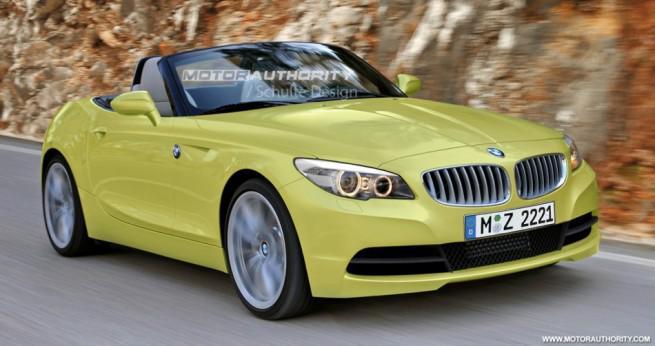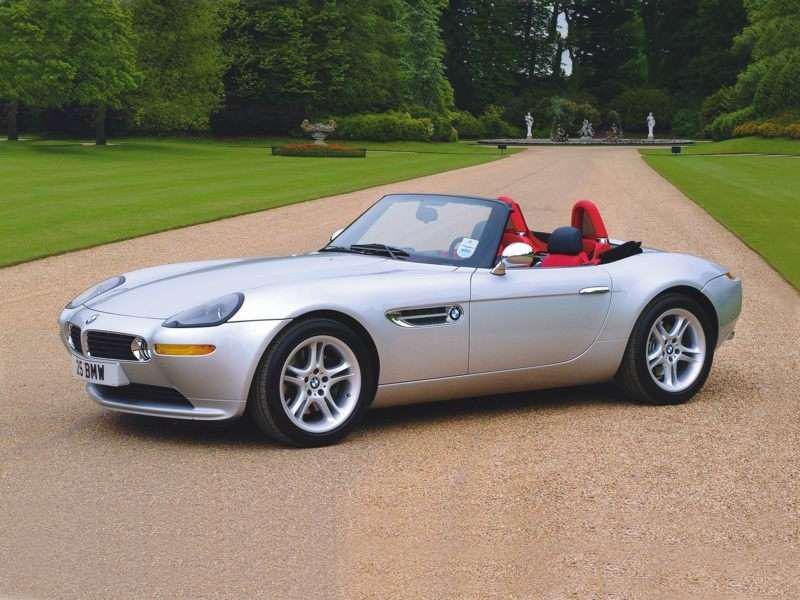The first image is the image on the left, the second image is the image on the right. Evaluate the accuracy of this statement regarding the images: "One of the cars is facing the left and has red seats while the other car faces the right and has beige seats.". Is it true? Answer yes or no. Yes. The first image is the image on the left, the second image is the image on the right. For the images displayed, is the sentence "The left image contains a white convertible that is parked facing towards the left." factually correct? Answer yes or no. No. 